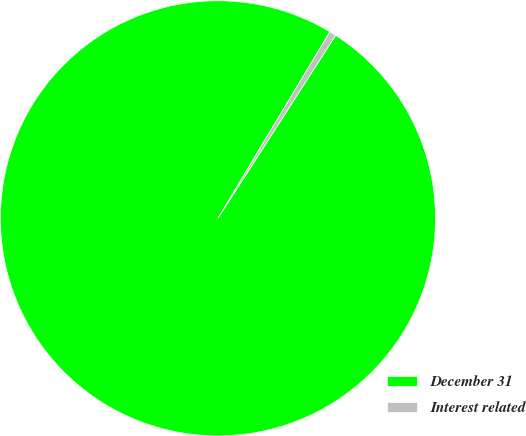Convert chart to OTSL. <chart><loc_0><loc_0><loc_500><loc_500><pie_chart><fcel>December 31<fcel>Interest related<nl><fcel>99.51%<fcel>0.49%<nl></chart> 